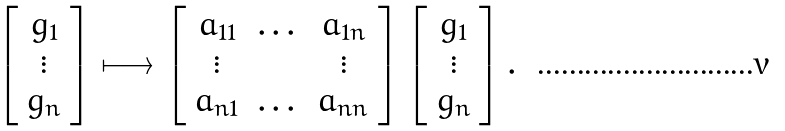Convert formula to latex. <formula><loc_0><loc_0><loc_500><loc_500>\left [ \begin{array} { c } g _ { 1 } \\ \vdots \\ g _ { n } \end{array} \right ] \longmapsto \left [ \begin{array} { c c c } a _ { 1 1 } & \dots & a _ { 1 n } \\ \vdots & & \vdots \\ a _ { n 1 } & \dots & a _ { n n } \end{array} \right ] \left [ \begin{array} { c } g _ { 1 } \\ \vdots \\ g _ { n } \end{array} \right ] .</formula> 